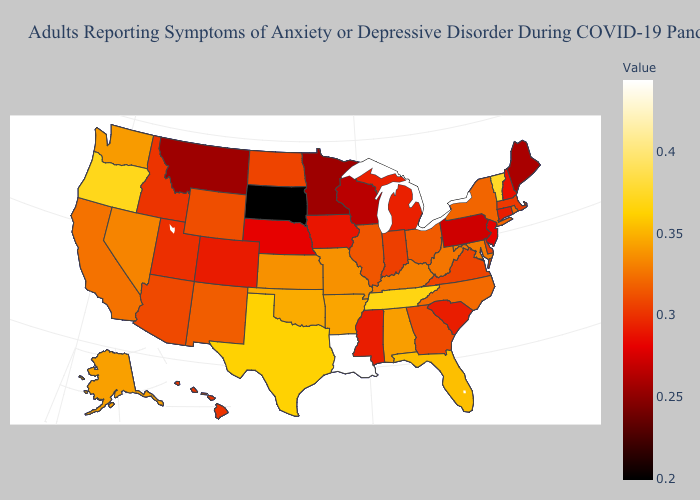Does the map have missing data?
Write a very short answer. No. Among the states that border Oregon , does Idaho have the highest value?
Write a very short answer. No. Does South Dakota have the lowest value in the USA?
Short answer required. Yes. 